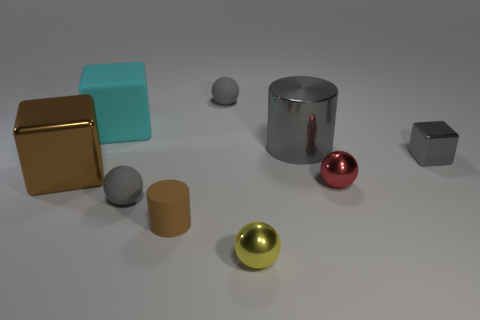Is the material of the large gray cylinder the same as the cyan cube?
Provide a short and direct response. No. The large shiny thing to the left of the tiny gray matte object behind the small red metallic object is what color?
Provide a succinct answer. Brown. There is a red ball that is the same material as the gray block; what is its size?
Your response must be concise. Small. What number of other big gray things are the same shape as the large gray object?
Provide a short and direct response. 0. How many things are either big things that are in front of the large gray metal cylinder or spheres that are in front of the small red metallic object?
Give a very brief answer. 3. How many red shiny spheres are behind the small matte object that is behind the cyan rubber cube?
Give a very brief answer. 0. There is a brown object on the right side of the big brown metal thing; does it have the same shape as the big shiny object that is right of the cyan rubber cube?
Provide a short and direct response. Yes. There is a thing that is the same color as the small cylinder; what shape is it?
Provide a short and direct response. Cube. Is there a ball made of the same material as the cyan object?
Ensure brevity in your answer.  Yes. What number of metal objects are either big cylinders or brown objects?
Your answer should be compact. 2. 